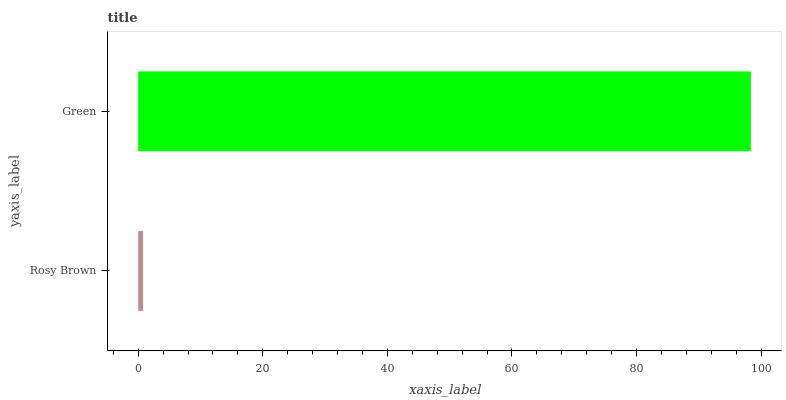Is Rosy Brown the minimum?
Answer yes or no. Yes. Is Green the maximum?
Answer yes or no. Yes. Is Green the minimum?
Answer yes or no. No. Is Green greater than Rosy Brown?
Answer yes or no. Yes. Is Rosy Brown less than Green?
Answer yes or no. Yes. Is Rosy Brown greater than Green?
Answer yes or no. No. Is Green less than Rosy Brown?
Answer yes or no. No. Is Green the high median?
Answer yes or no. Yes. Is Rosy Brown the low median?
Answer yes or no. Yes. Is Rosy Brown the high median?
Answer yes or no. No. Is Green the low median?
Answer yes or no. No. 